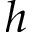Convert formula to latex. <formula><loc_0><loc_0><loc_500><loc_500>h</formula> 